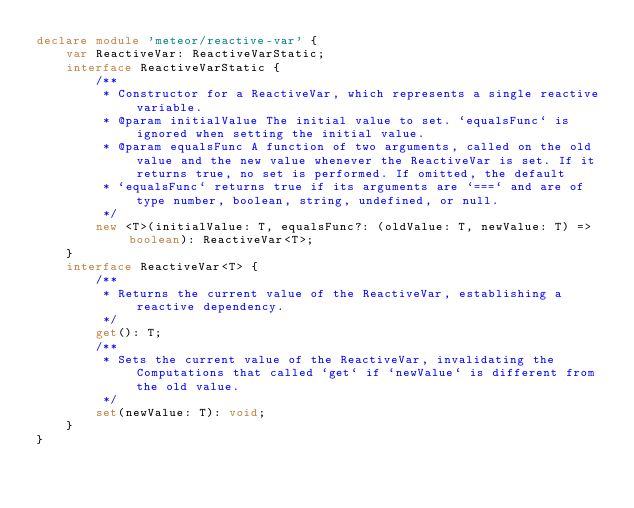<code> <loc_0><loc_0><loc_500><loc_500><_TypeScript_>declare module 'meteor/reactive-var' {
    var ReactiveVar: ReactiveVarStatic;
    interface ReactiveVarStatic {
        /**
         * Constructor for a ReactiveVar, which represents a single reactive variable.
         * @param initialValue The initial value to set. `equalsFunc` is ignored when setting the initial value.
         * @param equalsFunc A function of two arguments, called on the old value and the new value whenever the ReactiveVar is set. If it returns true, no set is performed. If omitted, the default
         * `equalsFunc` returns true if its arguments are `===` and are of type number, boolean, string, undefined, or null.
         */
        new <T>(initialValue: T, equalsFunc?: (oldValue: T, newValue: T) => boolean): ReactiveVar<T>;
    }
    interface ReactiveVar<T> {
        /**
         * Returns the current value of the ReactiveVar, establishing a reactive dependency.
         */
        get(): T;
        /**
         * Sets the current value of the ReactiveVar, invalidating the Computations that called `get` if `newValue` is different from the old value.
         */
        set(newValue: T): void;
    }
}
</code> 